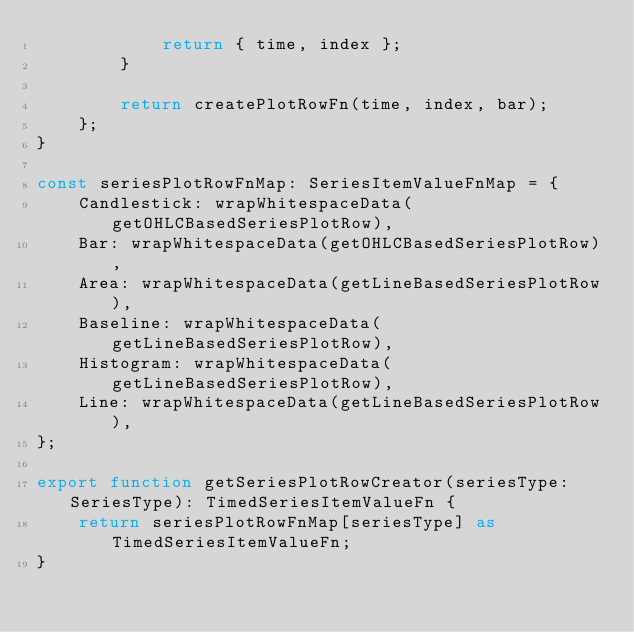<code> <loc_0><loc_0><loc_500><loc_500><_TypeScript_>			return { time, index };
		}

		return createPlotRowFn(time, index, bar);
	};
}

const seriesPlotRowFnMap: SeriesItemValueFnMap = {
	Candlestick: wrapWhitespaceData(getOHLCBasedSeriesPlotRow),
	Bar: wrapWhitespaceData(getOHLCBasedSeriesPlotRow),
	Area: wrapWhitespaceData(getLineBasedSeriesPlotRow),
	Baseline: wrapWhitespaceData(getLineBasedSeriesPlotRow),
	Histogram: wrapWhitespaceData(getLineBasedSeriesPlotRow),
	Line: wrapWhitespaceData(getLineBasedSeriesPlotRow),
};

export function getSeriesPlotRowCreator(seriesType: SeriesType): TimedSeriesItemValueFn {
	return seriesPlotRowFnMap[seriesType] as TimedSeriesItemValueFn;
}
</code> 